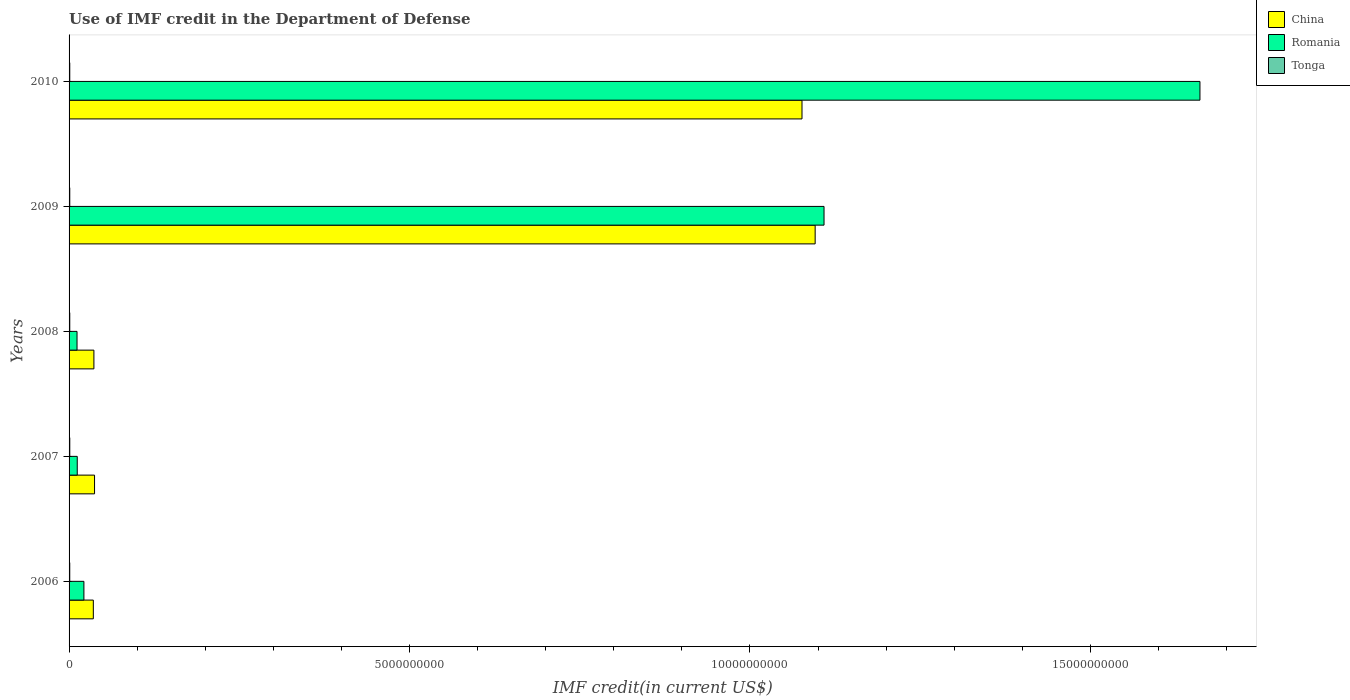Are the number of bars per tick equal to the number of legend labels?
Give a very brief answer. Yes. Are the number of bars on each tick of the Y-axis equal?
Your response must be concise. Yes. How many bars are there on the 5th tick from the bottom?
Your response must be concise. 3. What is the label of the 2nd group of bars from the top?
Your answer should be very brief. 2009. What is the IMF credit in the Department of Defense in China in 2008?
Give a very brief answer. 3.65e+08. Across all years, what is the maximum IMF credit in the Department of Defense in China?
Your answer should be compact. 1.10e+1. Across all years, what is the minimum IMF credit in the Department of Defense in Romania?
Ensure brevity in your answer.  1.17e+08. In which year was the IMF credit in the Department of Defense in Tonga minimum?
Provide a short and direct response. 2006. What is the total IMF credit in the Department of Defense in China in the graph?
Make the answer very short. 2.28e+1. What is the difference between the IMF credit in the Department of Defense in Tonga in 2006 and that in 2010?
Keep it short and to the point. -2.35e+05. What is the difference between the IMF credit in the Department of Defense in Romania in 2008 and the IMF credit in the Department of Defense in Tonga in 2007?
Your answer should be compact. 1.07e+08. What is the average IMF credit in the Department of Defense in Romania per year?
Offer a terse response. 5.63e+09. In the year 2010, what is the difference between the IMF credit in the Department of Defense in Tonga and IMF credit in the Department of Defense in China?
Your answer should be compact. -1.08e+1. In how many years, is the IMF credit in the Department of Defense in Tonga greater than 10000000000 US$?
Your answer should be very brief. 0. What is the ratio of the IMF credit in the Department of Defense in Romania in 2008 to that in 2010?
Offer a terse response. 0.01. What is the difference between the highest and the second highest IMF credit in the Department of Defense in China?
Offer a very short reply. 1.93e+08. What is the difference between the highest and the lowest IMF credit in the Department of Defense in Romania?
Your response must be concise. 1.65e+1. In how many years, is the IMF credit in the Department of Defense in China greater than the average IMF credit in the Department of Defense in China taken over all years?
Keep it short and to the point. 2. What does the 2nd bar from the top in 2007 represents?
Your response must be concise. Romania. What does the 2nd bar from the bottom in 2006 represents?
Your answer should be compact. Romania. Is it the case that in every year, the sum of the IMF credit in the Department of Defense in China and IMF credit in the Department of Defense in Tonga is greater than the IMF credit in the Department of Defense in Romania?
Your answer should be compact. No. Are all the bars in the graph horizontal?
Provide a short and direct response. Yes. What is the difference between two consecutive major ticks on the X-axis?
Offer a terse response. 5.00e+09. Are the values on the major ticks of X-axis written in scientific E-notation?
Make the answer very short. No. Where does the legend appear in the graph?
Your answer should be very brief. Top right. How many legend labels are there?
Offer a terse response. 3. How are the legend labels stacked?
Offer a terse response. Vertical. What is the title of the graph?
Offer a very short reply. Use of IMF credit in the Department of Defense. Does "Faeroe Islands" appear as one of the legend labels in the graph?
Your response must be concise. No. What is the label or title of the X-axis?
Offer a very short reply. IMF credit(in current US$). What is the label or title of the Y-axis?
Offer a terse response. Years. What is the IMF credit(in current US$) in China in 2006?
Provide a short and direct response. 3.56e+08. What is the IMF credit(in current US$) of Romania in 2006?
Your answer should be very brief. 2.18e+08. What is the IMF credit(in current US$) of Tonga in 2006?
Offer a terse response. 9.90e+06. What is the IMF credit(in current US$) in China in 2007?
Your response must be concise. 3.74e+08. What is the IMF credit(in current US$) of Romania in 2007?
Provide a short and direct response. 1.20e+08. What is the IMF credit(in current US$) of Tonga in 2007?
Offer a very short reply. 1.04e+07. What is the IMF credit(in current US$) in China in 2008?
Your answer should be compact. 3.65e+08. What is the IMF credit(in current US$) of Romania in 2008?
Ensure brevity in your answer.  1.17e+08. What is the IMF credit(in current US$) of Tonga in 2008?
Provide a succinct answer. 1.01e+07. What is the IMF credit(in current US$) in China in 2009?
Make the answer very short. 1.10e+1. What is the IMF credit(in current US$) in Romania in 2009?
Provide a succinct answer. 1.11e+1. What is the IMF credit(in current US$) in Tonga in 2009?
Offer a very short reply. 1.03e+07. What is the IMF credit(in current US$) of China in 2010?
Keep it short and to the point. 1.08e+1. What is the IMF credit(in current US$) of Romania in 2010?
Your answer should be very brief. 1.66e+1. What is the IMF credit(in current US$) of Tonga in 2010?
Your response must be concise. 1.01e+07. Across all years, what is the maximum IMF credit(in current US$) in China?
Provide a short and direct response. 1.10e+1. Across all years, what is the maximum IMF credit(in current US$) in Romania?
Ensure brevity in your answer.  1.66e+1. Across all years, what is the maximum IMF credit(in current US$) in Tonga?
Provide a short and direct response. 1.04e+07. Across all years, what is the minimum IMF credit(in current US$) in China?
Provide a succinct answer. 3.56e+08. Across all years, what is the minimum IMF credit(in current US$) of Romania?
Your response must be concise. 1.17e+08. Across all years, what is the minimum IMF credit(in current US$) of Tonga?
Provide a succinct answer. 9.90e+06. What is the total IMF credit(in current US$) of China in the graph?
Ensure brevity in your answer.  2.28e+1. What is the total IMF credit(in current US$) in Romania in the graph?
Your answer should be very brief. 2.82e+1. What is the total IMF credit(in current US$) of Tonga in the graph?
Your answer should be very brief. 5.09e+07. What is the difference between the IMF credit(in current US$) in China in 2006 and that in 2007?
Your answer should be compact. -1.80e+07. What is the difference between the IMF credit(in current US$) in Romania in 2006 and that in 2007?
Your response must be concise. 9.79e+07. What is the difference between the IMF credit(in current US$) in Tonga in 2006 and that in 2007?
Your answer should be compact. -4.99e+05. What is the difference between the IMF credit(in current US$) of China in 2006 and that in 2008?
Your answer should be very brief. -8.49e+06. What is the difference between the IMF credit(in current US$) of Romania in 2006 and that in 2008?
Your answer should be very brief. 1.01e+08. What is the difference between the IMF credit(in current US$) in Tonga in 2006 and that in 2008?
Your answer should be compact. -2.36e+05. What is the difference between the IMF credit(in current US$) in China in 2006 and that in 2009?
Your answer should be compact. -1.06e+1. What is the difference between the IMF credit(in current US$) in Romania in 2006 and that in 2009?
Provide a succinct answer. -1.09e+1. What is the difference between the IMF credit(in current US$) of Tonga in 2006 and that in 2009?
Provide a short and direct response. -4.17e+05. What is the difference between the IMF credit(in current US$) in China in 2006 and that in 2010?
Give a very brief answer. -1.04e+1. What is the difference between the IMF credit(in current US$) of Romania in 2006 and that in 2010?
Your answer should be very brief. -1.64e+1. What is the difference between the IMF credit(in current US$) of Tonga in 2006 and that in 2010?
Keep it short and to the point. -2.35e+05. What is the difference between the IMF credit(in current US$) of China in 2007 and that in 2008?
Ensure brevity in your answer.  9.47e+06. What is the difference between the IMF credit(in current US$) of Romania in 2007 and that in 2008?
Your response must be concise. 3.04e+06. What is the difference between the IMF credit(in current US$) in Tonga in 2007 and that in 2008?
Offer a very short reply. 2.63e+05. What is the difference between the IMF credit(in current US$) in China in 2007 and that in 2009?
Your answer should be very brief. -1.06e+1. What is the difference between the IMF credit(in current US$) in Romania in 2007 and that in 2009?
Provide a short and direct response. -1.10e+1. What is the difference between the IMF credit(in current US$) in Tonga in 2007 and that in 2009?
Keep it short and to the point. 8.20e+04. What is the difference between the IMF credit(in current US$) in China in 2007 and that in 2010?
Provide a short and direct response. -1.04e+1. What is the difference between the IMF credit(in current US$) in Romania in 2007 and that in 2010?
Provide a succinct answer. -1.65e+1. What is the difference between the IMF credit(in current US$) of Tonga in 2007 and that in 2010?
Offer a very short reply. 2.64e+05. What is the difference between the IMF credit(in current US$) of China in 2008 and that in 2009?
Ensure brevity in your answer.  -1.06e+1. What is the difference between the IMF credit(in current US$) in Romania in 2008 and that in 2009?
Ensure brevity in your answer.  -1.10e+1. What is the difference between the IMF credit(in current US$) of Tonga in 2008 and that in 2009?
Keep it short and to the point. -1.81e+05. What is the difference between the IMF credit(in current US$) of China in 2008 and that in 2010?
Your answer should be very brief. -1.04e+1. What is the difference between the IMF credit(in current US$) of Romania in 2008 and that in 2010?
Provide a succinct answer. -1.65e+1. What is the difference between the IMF credit(in current US$) of Tonga in 2008 and that in 2010?
Your answer should be compact. 1000. What is the difference between the IMF credit(in current US$) in China in 2009 and that in 2010?
Offer a very short reply. 1.93e+08. What is the difference between the IMF credit(in current US$) of Romania in 2009 and that in 2010?
Your response must be concise. -5.52e+09. What is the difference between the IMF credit(in current US$) of Tonga in 2009 and that in 2010?
Give a very brief answer. 1.82e+05. What is the difference between the IMF credit(in current US$) of China in 2006 and the IMF credit(in current US$) of Romania in 2007?
Offer a very short reply. 2.36e+08. What is the difference between the IMF credit(in current US$) in China in 2006 and the IMF credit(in current US$) in Tonga in 2007?
Ensure brevity in your answer.  3.46e+08. What is the difference between the IMF credit(in current US$) of Romania in 2006 and the IMF credit(in current US$) of Tonga in 2007?
Give a very brief answer. 2.07e+08. What is the difference between the IMF credit(in current US$) in China in 2006 and the IMF credit(in current US$) in Romania in 2008?
Your response must be concise. 2.39e+08. What is the difference between the IMF credit(in current US$) in China in 2006 and the IMF credit(in current US$) in Tonga in 2008?
Ensure brevity in your answer.  3.46e+08. What is the difference between the IMF credit(in current US$) of Romania in 2006 and the IMF credit(in current US$) of Tonga in 2008?
Provide a succinct answer. 2.08e+08. What is the difference between the IMF credit(in current US$) of China in 2006 and the IMF credit(in current US$) of Romania in 2009?
Your answer should be compact. -1.07e+1. What is the difference between the IMF credit(in current US$) in China in 2006 and the IMF credit(in current US$) in Tonga in 2009?
Give a very brief answer. 3.46e+08. What is the difference between the IMF credit(in current US$) in Romania in 2006 and the IMF credit(in current US$) in Tonga in 2009?
Give a very brief answer. 2.08e+08. What is the difference between the IMF credit(in current US$) in China in 2006 and the IMF credit(in current US$) in Romania in 2010?
Ensure brevity in your answer.  -1.63e+1. What is the difference between the IMF credit(in current US$) in China in 2006 and the IMF credit(in current US$) in Tonga in 2010?
Give a very brief answer. 3.46e+08. What is the difference between the IMF credit(in current US$) of Romania in 2006 and the IMF credit(in current US$) of Tonga in 2010?
Your answer should be compact. 2.08e+08. What is the difference between the IMF credit(in current US$) in China in 2007 and the IMF credit(in current US$) in Romania in 2008?
Your response must be concise. 2.57e+08. What is the difference between the IMF credit(in current US$) in China in 2007 and the IMF credit(in current US$) in Tonga in 2008?
Your answer should be compact. 3.64e+08. What is the difference between the IMF credit(in current US$) in Romania in 2007 and the IMF credit(in current US$) in Tonga in 2008?
Make the answer very short. 1.10e+08. What is the difference between the IMF credit(in current US$) in China in 2007 and the IMF credit(in current US$) in Romania in 2009?
Offer a very short reply. -1.07e+1. What is the difference between the IMF credit(in current US$) in China in 2007 and the IMF credit(in current US$) in Tonga in 2009?
Your answer should be very brief. 3.64e+08. What is the difference between the IMF credit(in current US$) in Romania in 2007 and the IMF credit(in current US$) in Tonga in 2009?
Provide a short and direct response. 1.10e+08. What is the difference between the IMF credit(in current US$) of China in 2007 and the IMF credit(in current US$) of Romania in 2010?
Keep it short and to the point. -1.62e+1. What is the difference between the IMF credit(in current US$) of China in 2007 and the IMF credit(in current US$) of Tonga in 2010?
Your answer should be very brief. 3.64e+08. What is the difference between the IMF credit(in current US$) in Romania in 2007 and the IMF credit(in current US$) in Tonga in 2010?
Provide a succinct answer. 1.10e+08. What is the difference between the IMF credit(in current US$) in China in 2008 and the IMF credit(in current US$) in Romania in 2009?
Your response must be concise. -1.07e+1. What is the difference between the IMF credit(in current US$) of China in 2008 and the IMF credit(in current US$) of Tonga in 2009?
Your answer should be very brief. 3.54e+08. What is the difference between the IMF credit(in current US$) in Romania in 2008 and the IMF credit(in current US$) in Tonga in 2009?
Provide a short and direct response. 1.07e+08. What is the difference between the IMF credit(in current US$) in China in 2008 and the IMF credit(in current US$) in Romania in 2010?
Your response must be concise. -1.62e+1. What is the difference between the IMF credit(in current US$) in China in 2008 and the IMF credit(in current US$) in Tonga in 2010?
Provide a short and direct response. 3.55e+08. What is the difference between the IMF credit(in current US$) of Romania in 2008 and the IMF credit(in current US$) of Tonga in 2010?
Keep it short and to the point. 1.07e+08. What is the difference between the IMF credit(in current US$) of China in 2009 and the IMF credit(in current US$) of Romania in 2010?
Provide a short and direct response. -5.65e+09. What is the difference between the IMF credit(in current US$) in China in 2009 and the IMF credit(in current US$) in Tonga in 2010?
Your answer should be very brief. 1.09e+1. What is the difference between the IMF credit(in current US$) in Romania in 2009 and the IMF credit(in current US$) in Tonga in 2010?
Offer a terse response. 1.11e+1. What is the average IMF credit(in current US$) of China per year?
Provide a succinct answer. 4.56e+09. What is the average IMF credit(in current US$) in Romania per year?
Make the answer very short. 5.63e+09. What is the average IMF credit(in current US$) in Tonga per year?
Give a very brief answer. 1.02e+07. In the year 2006, what is the difference between the IMF credit(in current US$) of China and IMF credit(in current US$) of Romania?
Keep it short and to the point. 1.38e+08. In the year 2006, what is the difference between the IMF credit(in current US$) in China and IMF credit(in current US$) in Tonga?
Make the answer very short. 3.46e+08. In the year 2006, what is the difference between the IMF credit(in current US$) of Romania and IMF credit(in current US$) of Tonga?
Give a very brief answer. 2.08e+08. In the year 2007, what is the difference between the IMF credit(in current US$) of China and IMF credit(in current US$) of Romania?
Provide a short and direct response. 2.54e+08. In the year 2007, what is the difference between the IMF credit(in current US$) in China and IMF credit(in current US$) in Tonga?
Your answer should be very brief. 3.64e+08. In the year 2007, what is the difference between the IMF credit(in current US$) in Romania and IMF credit(in current US$) in Tonga?
Your response must be concise. 1.10e+08. In the year 2008, what is the difference between the IMF credit(in current US$) in China and IMF credit(in current US$) in Romania?
Your answer should be very brief. 2.48e+08. In the year 2008, what is the difference between the IMF credit(in current US$) of China and IMF credit(in current US$) of Tonga?
Offer a terse response. 3.55e+08. In the year 2008, what is the difference between the IMF credit(in current US$) of Romania and IMF credit(in current US$) of Tonga?
Make the answer very short. 1.07e+08. In the year 2009, what is the difference between the IMF credit(in current US$) of China and IMF credit(in current US$) of Romania?
Your answer should be very brief. -1.30e+08. In the year 2009, what is the difference between the IMF credit(in current US$) of China and IMF credit(in current US$) of Tonga?
Provide a short and direct response. 1.09e+1. In the year 2009, what is the difference between the IMF credit(in current US$) of Romania and IMF credit(in current US$) of Tonga?
Offer a very short reply. 1.11e+1. In the year 2010, what is the difference between the IMF credit(in current US$) in China and IMF credit(in current US$) in Romania?
Give a very brief answer. -5.84e+09. In the year 2010, what is the difference between the IMF credit(in current US$) of China and IMF credit(in current US$) of Tonga?
Your response must be concise. 1.08e+1. In the year 2010, what is the difference between the IMF credit(in current US$) of Romania and IMF credit(in current US$) of Tonga?
Offer a terse response. 1.66e+1. What is the ratio of the IMF credit(in current US$) of Romania in 2006 to that in 2007?
Your response must be concise. 1.82. What is the ratio of the IMF credit(in current US$) in China in 2006 to that in 2008?
Make the answer very short. 0.98. What is the ratio of the IMF credit(in current US$) in Romania in 2006 to that in 2008?
Provide a short and direct response. 1.86. What is the ratio of the IMF credit(in current US$) in Tonga in 2006 to that in 2008?
Ensure brevity in your answer.  0.98. What is the ratio of the IMF credit(in current US$) in China in 2006 to that in 2009?
Your answer should be very brief. 0.03. What is the ratio of the IMF credit(in current US$) of Romania in 2006 to that in 2009?
Make the answer very short. 0.02. What is the ratio of the IMF credit(in current US$) of Tonga in 2006 to that in 2009?
Provide a succinct answer. 0.96. What is the ratio of the IMF credit(in current US$) of China in 2006 to that in 2010?
Ensure brevity in your answer.  0.03. What is the ratio of the IMF credit(in current US$) of Romania in 2006 to that in 2010?
Ensure brevity in your answer.  0.01. What is the ratio of the IMF credit(in current US$) of Tonga in 2006 to that in 2010?
Provide a short and direct response. 0.98. What is the ratio of the IMF credit(in current US$) of China in 2007 to that in 2008?
Give a very brief answer. 1.03. What is the ratio of the IMF credit(in current US$) in Romania in 2007 to that in 2008?
Offer a terse response. 1.03. What is the ratio of the IMF credit(in current US$) in Tonga in 2007 to that in 2008?
Your answer should be very brief. 1.03. What is the ratio of the IMF credit(in current US$) in China in 2007 to that in 2009?
Your answer should be very brief. 0.03. What is the ratio of the IMF credit(in current US$) in Romania in 2007 to that in 2009?
Provide a succinct answer. 0.01. What is the ratio of the IMF credit(in current US$) of Tonga in 2007 to that in 2009?
Your response must be concise. 1.01. What is the ratio of the IMF credit(in current US$) in China in 2007 to that in 2010?
Keep it short and to the point. 0.03. What is the ratio of the IMF credit(in current US$) in Romania in 2007 to that in 2010?
Provide a succinct answer. 0.01. What is the ratio of the IMF credit(in current US$) in Tonga in 2007 to that in 2010?
Provide a short and direct response. 1.03. What is the ratio of the IMF credit(in current US$) in China in 2008 to that in 2009?
Keep it short and to the point. 0.03. What is the ratio of the IMF credit(in current US$) in Romania in 2008 to that in 2009?
Offer a terse response. 0.01. What is the ratio of the IMF credit(in current US$) of Tonga in 2008 to that in 2009?
Your answer should be very brief. 0.98. What is the ratio of the IMF credit(in current US$) of China in 2008 to that in 2010?
Give a very brief answer. 0.03. What is the ratio of the IMF credit(in current US$) in Romania in 2008 to that in 2010?
Your response must be concise. 0.01. What is the ratio of the IMF credit(in current US$) in Romania in 2009 to that in 2010?
Your answer should be very brief. 0.67. What is the difference between the highest and the second highest IMF credit(in current US$) in China?
Your answer should be compact. 1.93e+08. What is the difference between the highest and the second highest IMF credit(in current US$) of Romania?
Give a very brief answer. 5.52e+09. What is the difference between the highest and the second highest IMF credit(in current US$) in Tonga?
Your answer should be compact. 8.20e+04. What is the difference between the highest and the lowest IMF credit(in current US$) in China?
Keep it short and to the point. 1.06e+1. What is the difference between the highest and the lowest IMF credit(in current US$) in Romania?
Provide a short and direct response. 1.65e+1. What is the difference between the highest and the lowest IMF credit(in current US$) in Tonga?
Your response must be concise. 4.99e+05. 